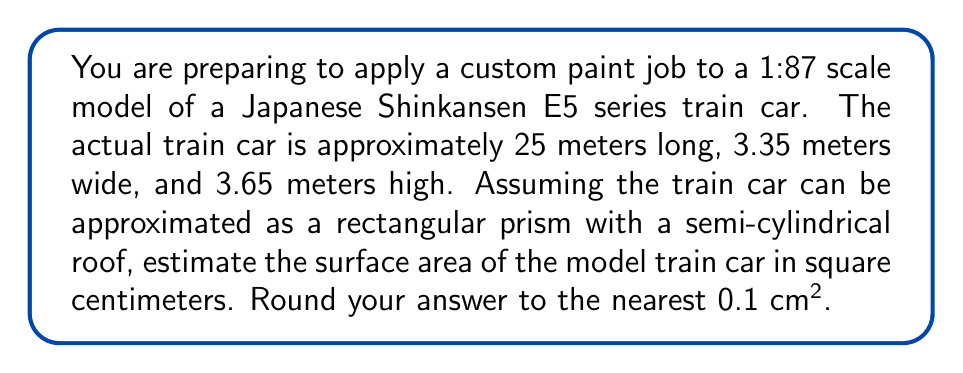Can you solve this math problem? To solve this problem, we'll follow these steps:

1) First, let's calculate the dimensions of the model train car:
   Length: $\frac{25 \text{ m}}{87} = 0.2874 \text{ m} = 28.74 \text{ cm}$
   Width: $\frac{3.35 \text{ m}}{87} = 0.0385 \text{ m} = 3.85 \text{ cm}$
   Height: $\frac{3.65 \text{ m}}{87} = 0.0420 \text{ m} = 4.20 \text{ cm}$

2) The surface area will consist of:
   - Two rectangular ends
   - Two rectangular sides
   - One rectangular bottom
   - One semi-cylindrical roof

3) Calculate the area of the ends:
   $A_{ends} = 2 \cdot (3.85 \text{ cm} \cdot 4.20 \text{ cm}) = 32.34 \text{ cm}^2$

4) Calculate the area of the sides:
   $A_{sides} = 2 \cdot (28.74 \text{ cm} \cdot 4.20 \text{ cm}) = 241.42 \text{ cm}^2$

5) Calculate the area of the bottom:
   $A_{bottom} = 28.74 \text{ cm} \cdot 3.85 \text{ cm} = 110.65 \text{ cm}^2$

6) Calculate the area of the semi-cylindrical roof:
   The circumference of a full circle would be $\pi \cdot 3.85 \text{ cm} = 12.09 \text{ cm}$
   Half of this for the semi-circle is $6.045 \text{ cm}$
   $A_{roof} = 28.74 \text{ cm} \cdot 6.045 \text{ cm} = 173.73 \text{ cm}^2$

7) Sum all the areas:
   $A_{total} = A_{ends} + A_{sides} + A_{bottom} + A_{roof}$
   $A_{total} = 32.34 + 241.42 + 110.65 + 173.73 = 558.14 \text{ cm}^2$

8) Rounding to the nearest 0.1 cm²:
   $A_{total} \approx 558.1 \text{ cm}^2$
Answer: $558.1 \text{ cm}^2$ 